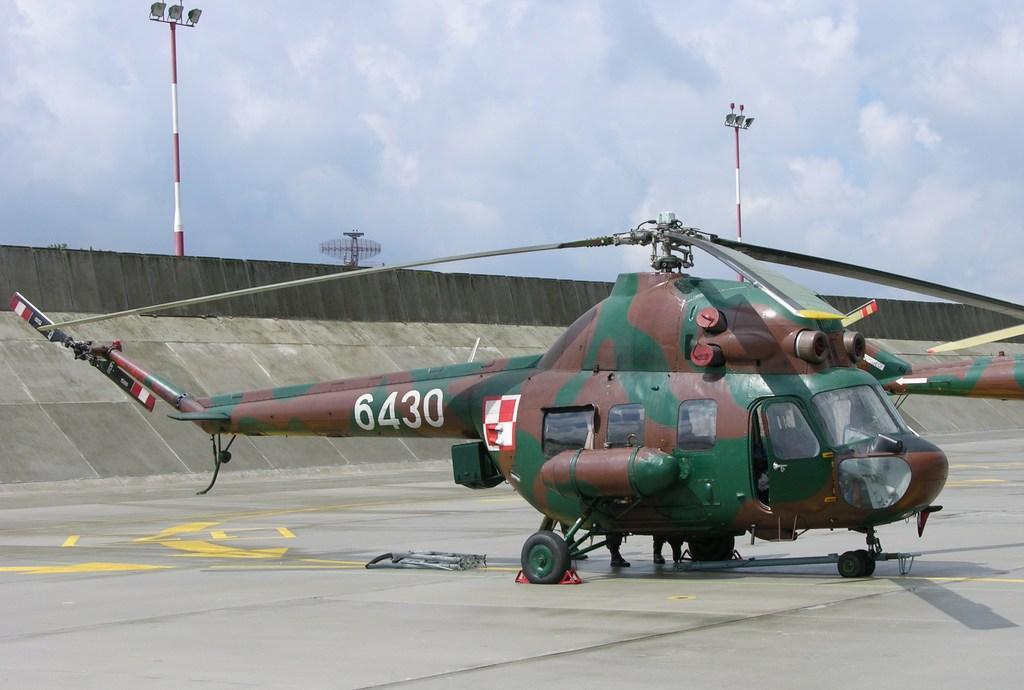Describe this image in one or two sentences. In this picture we can see a helicopter on the ground, wall, poles and in the background we can see the sky with clouds. 